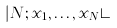Convert formula to latex. <formula><loc_0><loc_0><loc_500><loc_500>| N ; x _ { 1 } , \dots , x _ { N } \rangle</formula> 